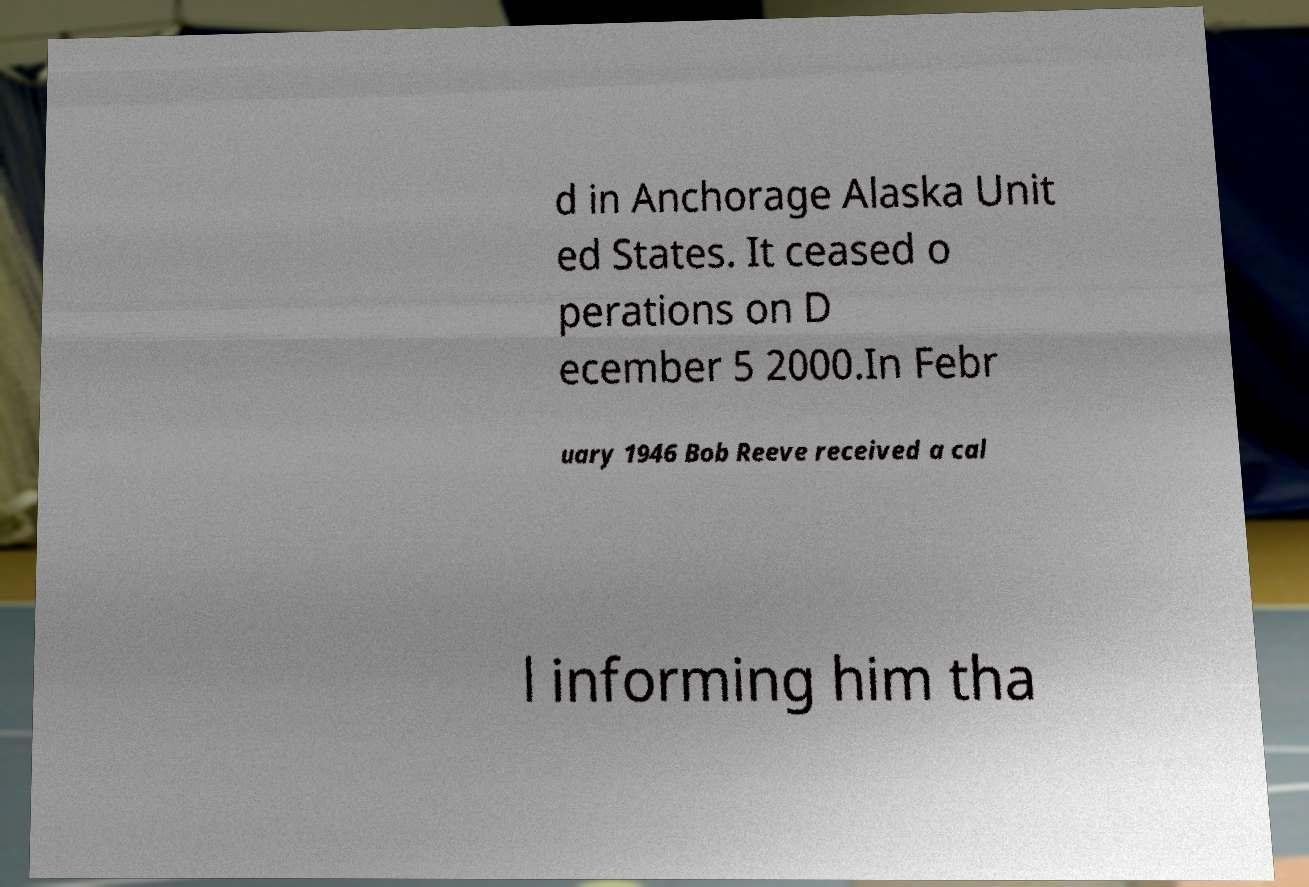What messages or text are displayed in this image? I need them in a readable, typed format. d in Anchorage Alaska Unit ed States. It ceased o perations on D ecember 5 2000.In Febr uary 1946 Bob Reeve received a cal l informing him tha 